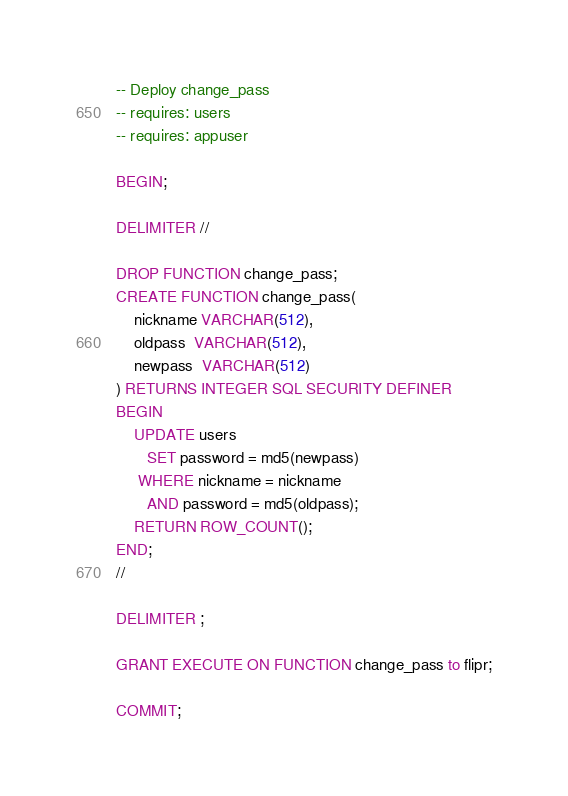<code> <loc_0><loc_0><loc_500><loc_500><_SQL_>-- Deploy change_pass
-- requires: users
-- requires: appuser

BEGIN;

DELIMITER //

DROP FUNCTION change_pass;
CREATE FUNCTION change_pass(
    nickname VARCHAR(512),
    oldpass  VARCHAR(512),
    newpass  VARCHAR(512)
) RETURNS INTEGER SQL SECURITY DEFINER
BEGIN
    UPDATE users
       SET password = md5(newpass)
     WHERE nickname = nickname
       AND password = md5(oldpass);
    RETURN ROW_COUNT();
END;
//

DELIMITER ;

GRANT EXECUTE ON FUNCTION change_pass to flipr;

COMMIT;
</code> 